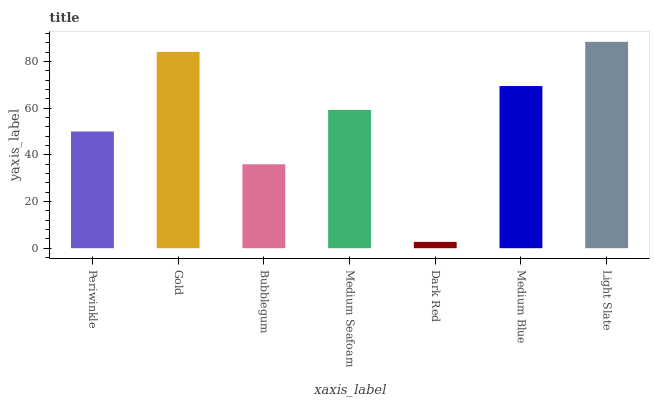Is Gold the minimum?
Answer yes or no. No. Is Gold the maximum?
Answer yes or no. No. Is Gold greater than Periwinkle?
Answer yes or no. Yes. Is Periwinkle less than Gold?
Answer yes or no. Yes. Is Periwinkle greater than Gold?
Answer yes or no. No. Is Gold less than Periwinkle?
Answer yes or no. No. Is Medium Seafoam the high median?
Answer yes or no. Yes. Is Medium Seafoam the low median?
Answer yes or no. Yes. Is Gold the high median?
Answer yes or no. No. Is Dark Red the low median?
Answer yes or no. No. 